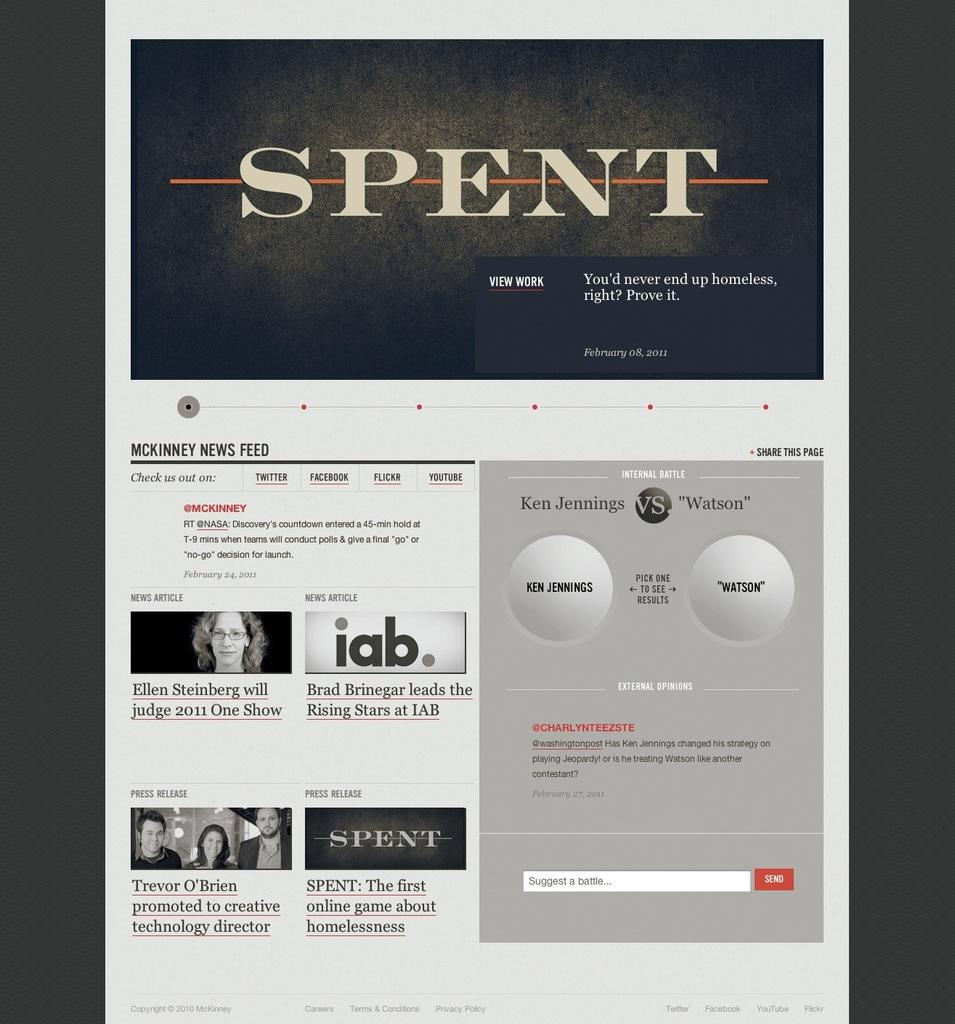<image>
Describe the image concisely. The Magazine Spent, asks questions about being homeless. 